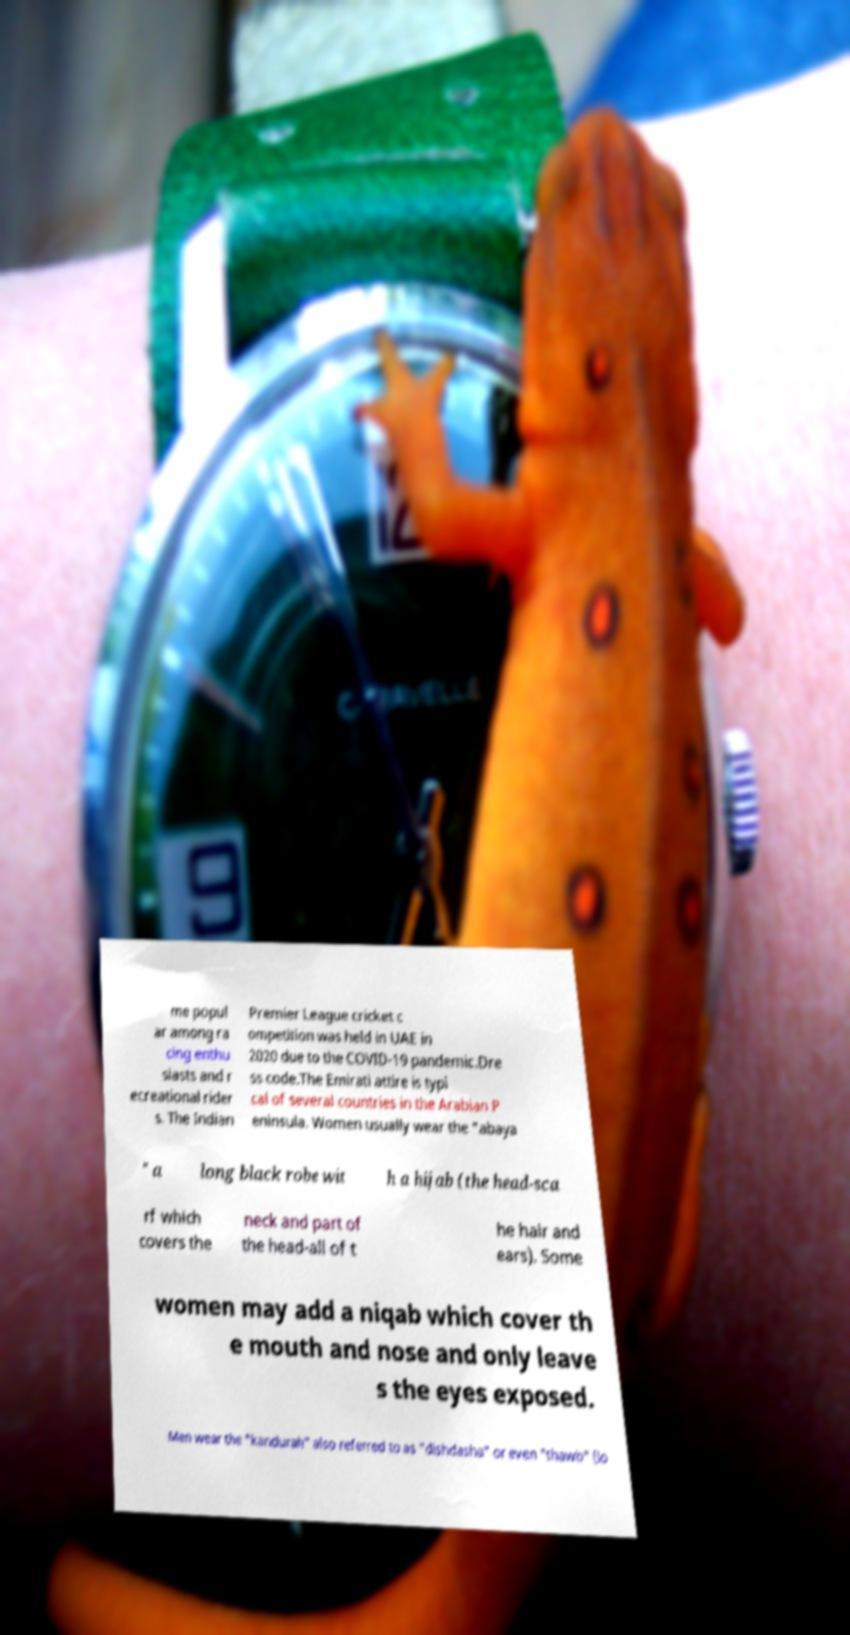Please identify and transcribe the text found in this image. me popul ar among ra cing enthu siasts and r ecreational rider s. The Indian Premier League cricket c ompetition was held in UAE in 2020 due to the COVID-19 pandemic.Dre ss code.The Emirati attire is typi cal of several countries in the Arabian P eninsula. Women usually wear the "abaya " a long black robe wit h a hijab (the head-sca rf which covers the neck and part of the head-all of t he hair and ears). Some women may add a niqab which cover th e mouth and nose and only leave s the eyes exposed. Men wear the "kandurah" also referred to as "dishdasha" or even "thawb" (lo 